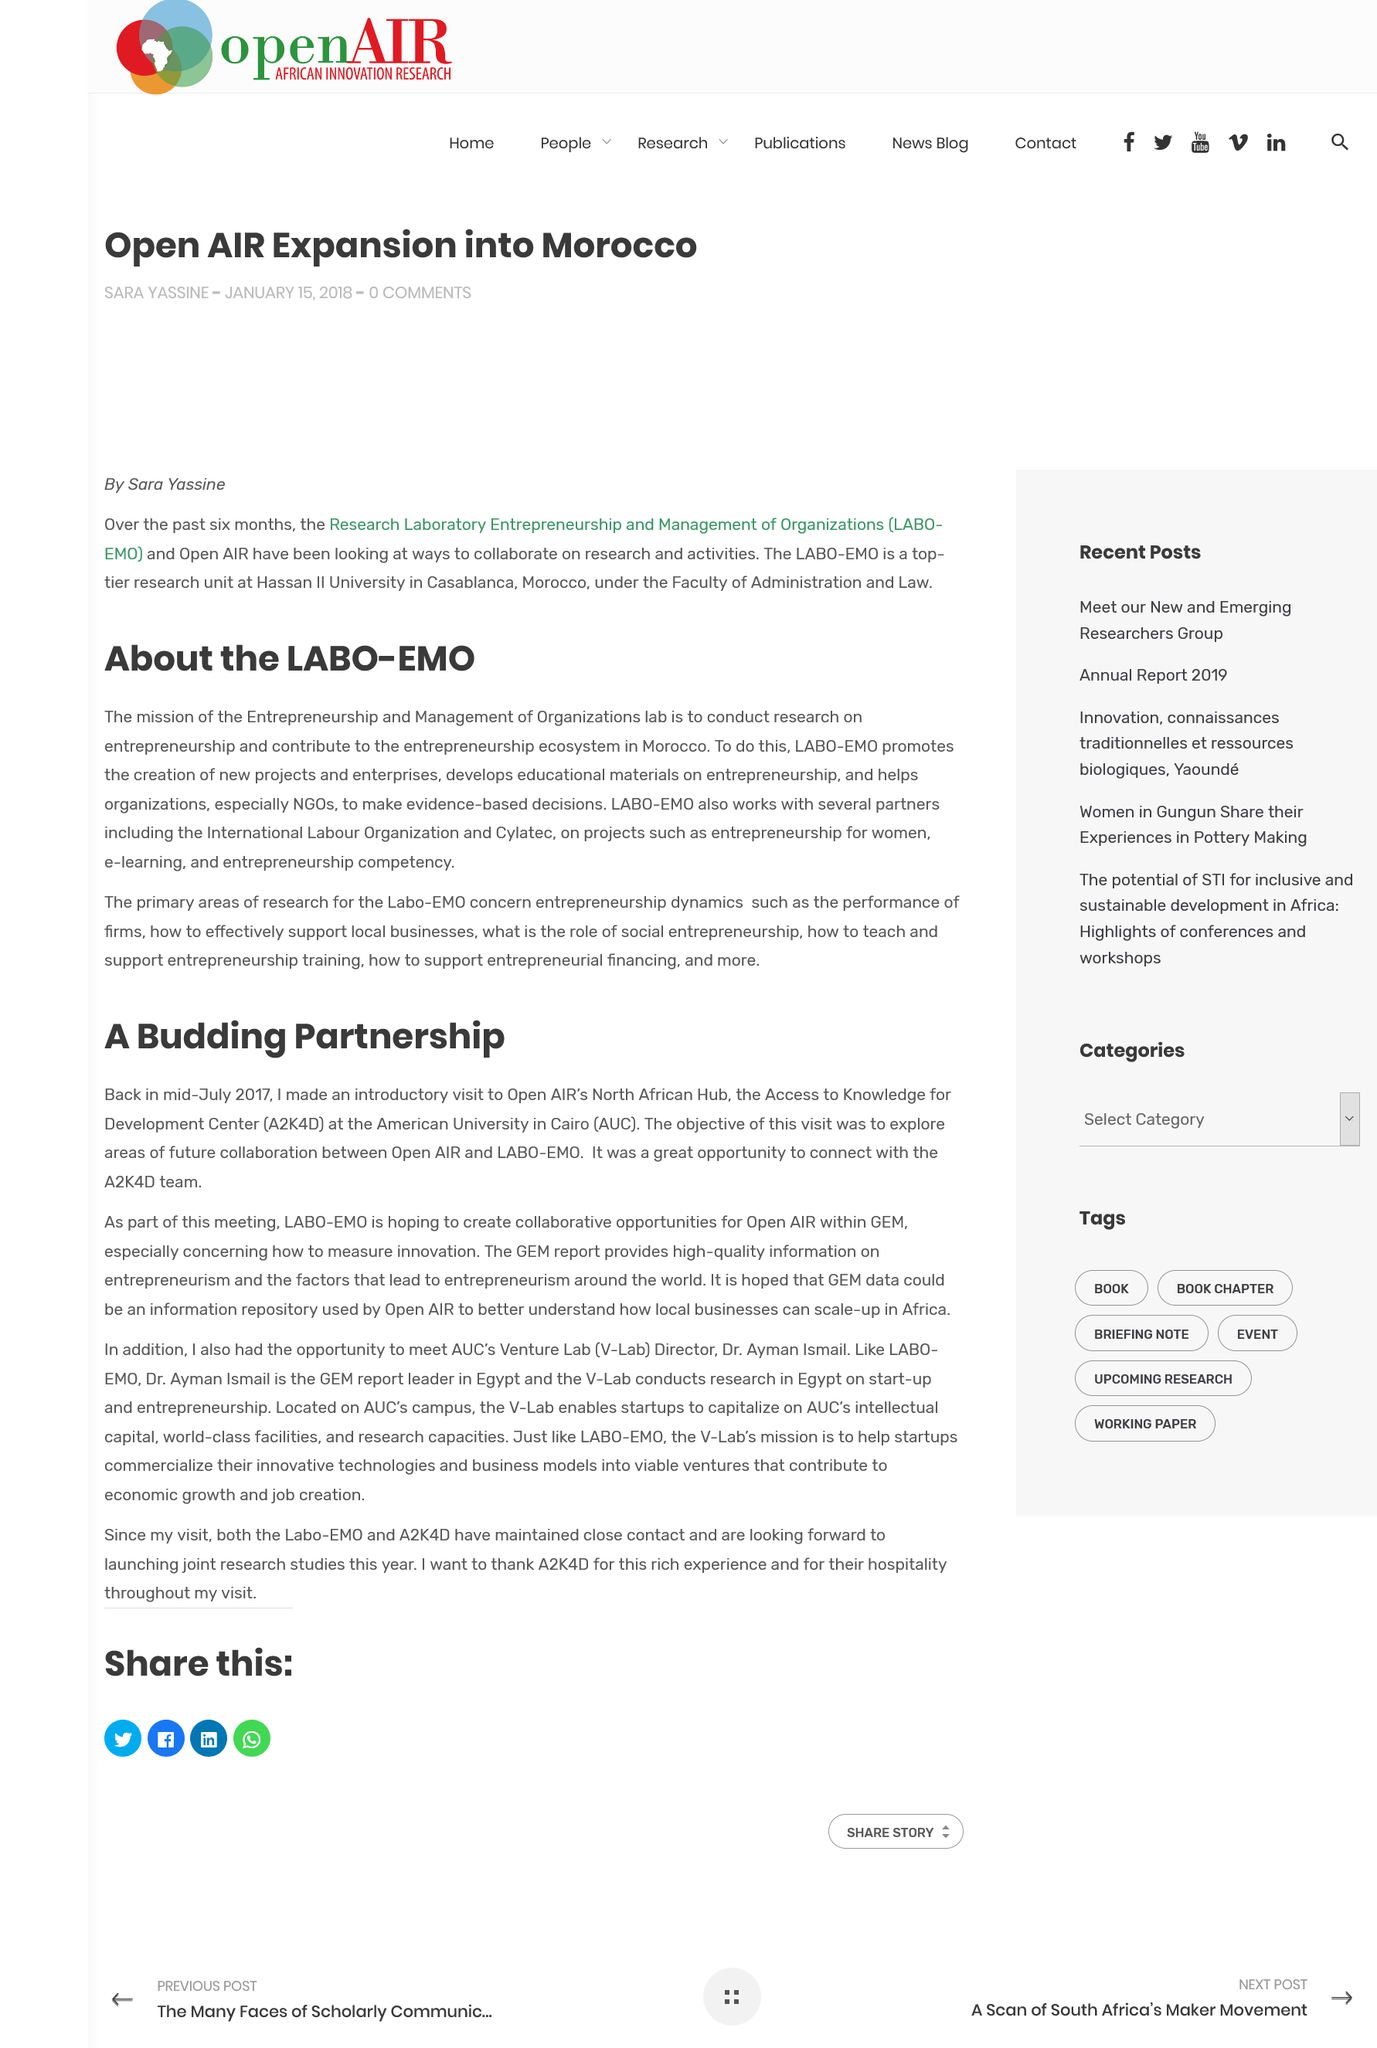Specify some key components in this picture. The primary areas of research for the Labo-EMO focus on understanding the dynamics of entrepreneurship, including the performance of firms, the impact of local businesses, the role of social entrepreneurship, and the effective teaching and support of entrepreneurship training and financing. LABO-EMO partners with several organizations, such as the International Labour Organization and Cylatec, to provide high-quality services and support. The Entrepreneurship and Management of Organizations lab aims to conduct research on entrepreneurship and contribute to the development of the entrepreneurship ecosystem in Morocco. 